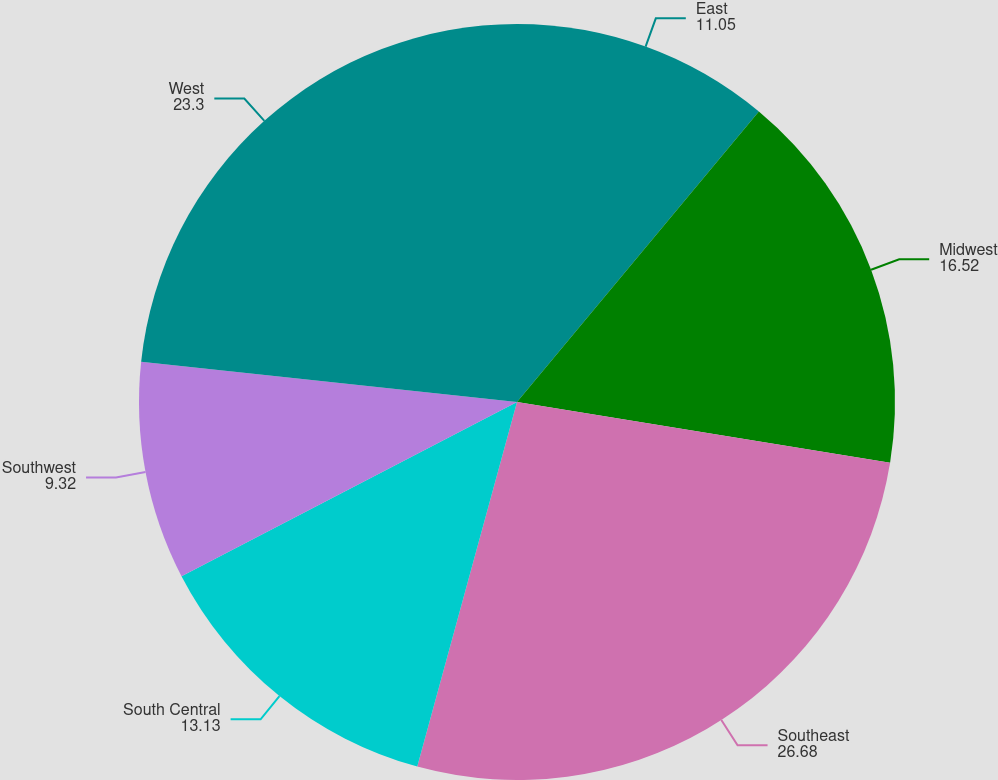<chart> <loc_0><loc_0><loc_500><loc_500><pie_chart><fcel>East<fcel>Midwest<fcel>Southeast<fcel>South Central<fcel>Southwest<fcel>West<nl><fcel>11.05%<fcel>16.52%<fcel>26.68%<fcel>13.13%<fcel>9.32%<fcel>23.3%<nl></chart> 